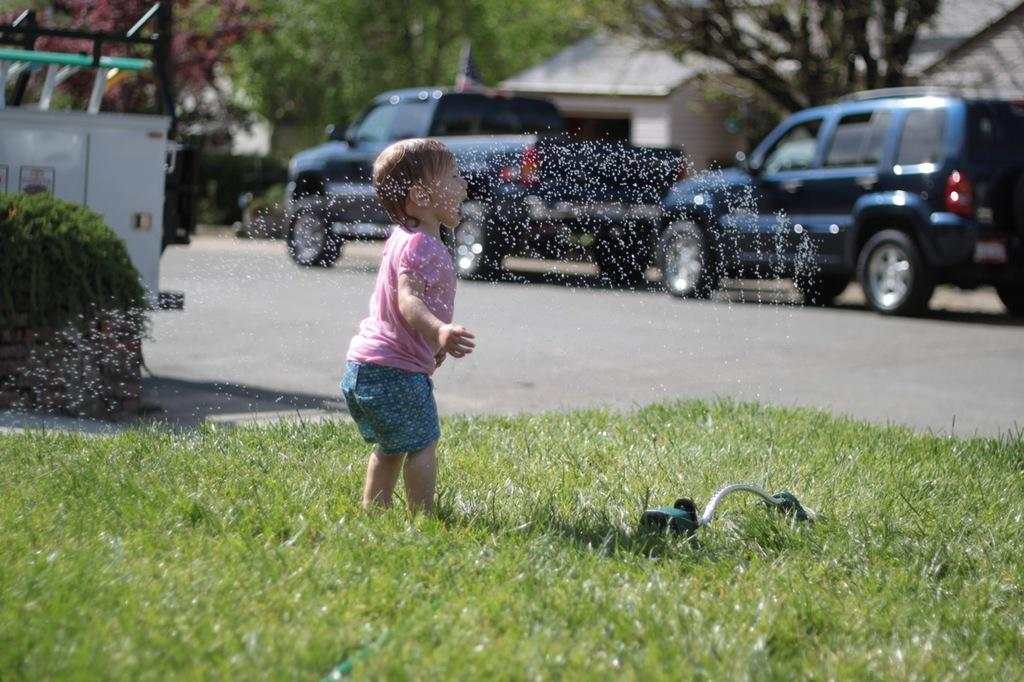What is the main subject of the image? There is a kid in the image. What is located on the grass in the image? There is an object on the grass. What can be seen on the road in the image? There are vehicles on the road in the image. What is visible in the background of the image? There are trees and buildings in the background of the image. What type of crack can be seen in the image? There is no crack present in the image. How does the kid stretch in the image? The image does not show the kid stretching; it only shows the kid standing or sitting. 